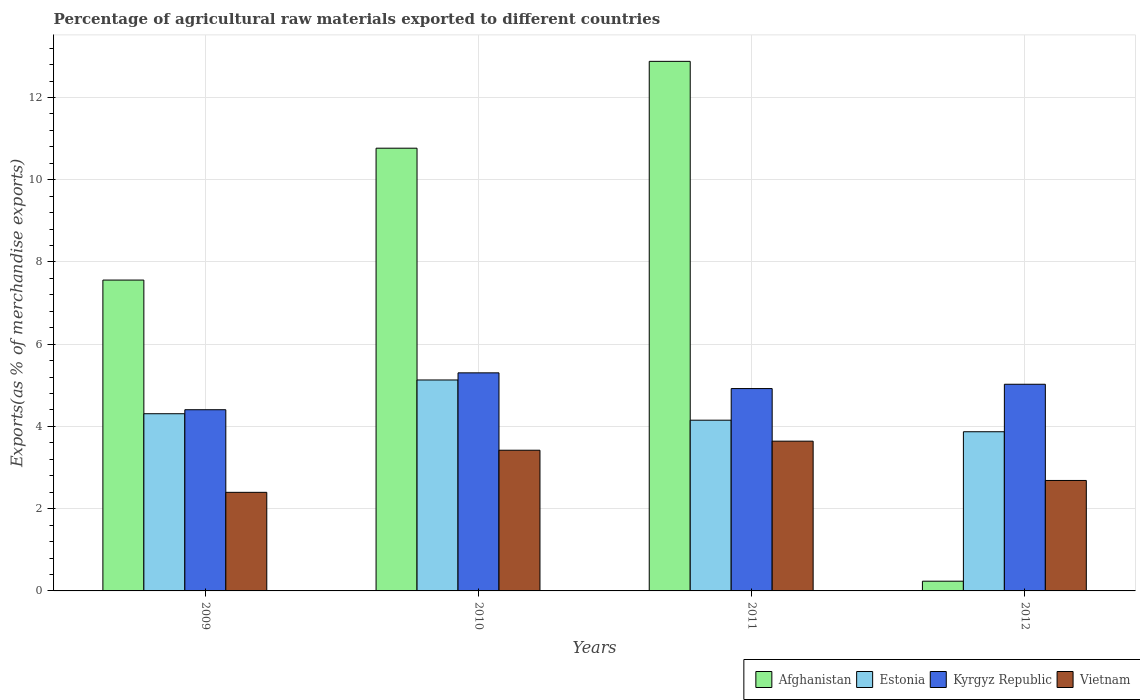How many different coloured bars are there?
Your answer should be compact. 4. Are the number of bars per tick equal to the number of legend labels?
Your answer should be compact. Yes. How many bars are there on the 4th tick from the right?
Keep it short and to the point. 4. What is the percentage of exports to different countries in Kyrgyz Republic in 2010?
Provide a succinct answer. 5.3. Across all years, what is the maximum percentage of exports to different countries in Vietnam?
Provide a short and direct response. 3.64. Across all years, what is the minimum percentage of exports to different countries in Afghanistan?
Make the answer very short. 0.24. In which year was the percentage of exports to different countries in Estonia maximum?
Give a very brief answer. 2010. What is the total percentage of exports to different countries in Afghanistan in the graph?
Your answer should be compact. 31.44. What is the difference between the percentage of exports to different countries in Kyrgyz Republic in 2009 and that in 2010?
Provide a succinct answer. -0.9. What is the difference between the percentage of exports to different countries in Estonia in 2010 and the percentage of exports to different countries in Afghanistan in 2012?
Your answer should be very brief. 4.89. What is the average percentage of exports to different countries in Estonia per year?
Your response must be concise. 4.37. In the year 2010, what is the difference between the percentage of exports to different countries in Afghanistan and percentage of exports to different countries in Kyrgyz Republic?
Provide a short and direct response. 5.46. What is the ratio of the percentage of exports to different countries in Estonia in 2010 to that in 2011?
Ensure brevity in your answer.  1.24. Is the percentage of exports to different countries in Afghanistan in 2010 less than that in 2012?
Ensure brevity in your answer.  No. What is the difference between the highest and the second highest percentage of exports to different countries in Vietnam?
Your response must be concise. 0.22. What is the difference between the highest and the lowest percentage of exports to different countries in Estonia?
Your response must be concise. 1.26. Is it the case that in every year, the sum of the percentage of exports to different countries in Kyrgyz Republic and percentage of exports to different countries in Afghanistan is greater than the sum of percentage of exports to different countries in Vietnam and percentage of exports to different countries in Estonia?
Your response must be concise. No. What does the 1st bar from the left in 2011 represents?
Provide a succinct answer. Afghanistan. What does the 1st bar from the right in 2010 represents?
Make the answer very short. Vietnam. Is it the case that in every year, the sum of the percentage of exports to different countries in Estonia and percentage of exports to different countries in Afghanistan is greater than the percentage of exports to different countries in Vietnam?
Offer a very short reply. Yes. Are all the bars in the graph horizontal?
Ensure brevity in your answer.  No. What is the difference between two consecutive major ticks on the Y-axis?
Ensure brevity in your answer.  2. Are the values on the major ticks of Y-axis written in scientific E-notation?
Provide a short and direct response. No. Does the graph contain any zero values?
Give a very brief answer. No. Does the graph contain grids?
Your answer should be compact. Yes. Where does the legend appear in the graph?
Your answer should be compact. Bottom right. How many legend labels are there?
Your response must be concise. 4. How are the legend labels stacked?
Give a very brief answer. Horizontal. What is the title of the graph?
Provide a succinct answer. Percentage of agricultural raw materials exported to different countries. What is the label or title of the Y-axis?
Ensure brevity in your answer.  Exports(as % of merchandise exports). What is the Exports(as % of merchandise exports) of Afghanistan in 2009?
Ensure brevity in your answer.  7.56. What is the Exports(as % of merchandise exports) of Estonia in 2009?
Ensure brevity in your answer.  4.31. What is the Exports(as % of merchandise exports) of Kyrgyz Republic in 2009?
Ensure brevity in your answer.  4.41. What is the Exports(as % of merchandise exports) of Vietnam in 2009?
Offer a very short reply. 2.4. What is the Exports(as % of merchandise exports) in Afghanistan in 2010?
Offer a very short reply. 10.77. What is the Exports(as % of merchandise exports) of Estonia in 2010?
Make the answer very short. 5.13. What is the Exports(as % of merchandise exports) of Kyrgyz Republic in 2010?
Provide a short and direct response. 5.3. What is the Exports(as % of merchandise exports) in Vietnam in 2010?
Your answer should be very brief. 3.42. What is the Exports(as % of merchandise exports) of Afghanistan in 2011?
Ensure brevity in your answer.  12.88. What is the Exports(as % of merchandise exports) of Estonia in 2011?
Your answer should be compact. 4.15. What is the Exports(as % of merchandise exports) of Kyrgyz Republic in 2011?
Offer a terse response. 4.92. What is the Exports(as % of merchandise exports) of Vietnam in 2011?
Provide a succinct answer. 3.64. What is the Exports(as % of merchandise exports) in Afghanistan in 2012?
Offer a terse response. 0.24. What is the Exports(as % of merchandise exports) in Estonia in 2012?
Your answer should be very brief. 3.87. What is the Exports(as % of merchandise exports) of Kyrgyz Republic in 2012?
Ensure brevity in your answer.  5.03. What is the Exports(as % of merchandise exports) of Vietnam in 2012?
Your answer should be very brief. 2.69. Across all years, what is the maximum Exports(as % of merchandise exports) in Afghanistan?
Your response must be concise. 12.88. Across all years, what is the maximum Exports(as % of merchandise exports) of Estonia?
Your answer should be very brief. 5.13. Across all years, what is the maximum Exports(as % of merchandise exports) of Kyrgyz Republic?
Your answer should be very brief. 5.3. Across all years, what is the maximum Exports(as % of merchandise exports) of Vietnam?
Provide a succinct answer. 3.64. Across all years, what is the minimum Exports(as % of merchandise exports) in Afghanistan?
Provide a succinct answer. 0.24. Across all years, what is the minimum Exports(as % of merchandise exports) of Estonia?
Provide a short and direct response. 3.87. Across all years, what is the minimum Exports(as % of merchandise exports) of Kyrgyz Republic?
Offer a terse response. 4.41. Across all years, what is the minimum Exports(as % of merchandise exports) of Vietnam?
Keep it short and to the point. 2.4. What is the total Exports(as % of merchandise exports) in Afghanistan in the graph?
Your answer should be compact. 31.44. What is the total Exports(as % of merchandise exports) in Estonia in the graph?
Ensure brevity in your answer.  17.46. What is the total Exports(as % of merchandise exports) in Kyrgyz Republic in the graph?
Offer a very short reply. 19.66. What is the total Exports(as % of merchandise exports) of Vietnam in the graph?
Provide a short and direct response. 12.15. What is the difference between the Exports(as % of merchandise exports) of Afghanistan in 2009 and that in 2010?
Keep it short and to the point. -3.21. What is the difference between the Exports(as % of merchandise exports) in Estonia in 2009 and that in 2010?
Offer a terse response. -0.82. What is the difference between the Exports(as % of merchandise exports) in Kyrgyz Republic in 2009 and that in 2010?
Make the answer very short. -0.9. What is the difference between the Exports(as % of merchandise exports) in Vietnam in 2009 and that in 2010?
Ensure brevity in your answer.  -1.02. What is the difference between the Exports(as % of merchandise exports) of Afghanistan in 2009 and that in 2011?
Offer a very short reply. -5.32. What is the difference between the Exports(as % of merchandise exports) in Estonia in 2009 and that in 2011?
Keep it short and to the point. 0.16. What is the difference between the Exports(as % of merchandise exports) of Kyrgyz Republic in 2009 and that in 2011?
Your response must be concise. -0.51. What is the difference between the Exports(as % of merchandise exports) of Vietnam in 2009 and that in 2011?
Keep it short and to the point. -1.24. What is the difference between the Exports(as % of merchandise exports) of Afghanistan in 2009 and that in 2012?
Your answer should be very brief. 7.32. What is the difference between the Exports(as % of merchandise exports) of Estonia in 2009 and that in 2012?
Your answer should be very brief. 0.44. What is the difference between the Exports(as % of merchandise exports) in Kyrgyz Republic in 2009 and that in 2012?
Offer a terse response. -0.62. What is the difference between the Exports(as % of merchandise exports) of Vietnam in 2009 and that in 2012?
Your answer should be very brief. -0.29. What is the difference between the Exports(as % of merchandise exports) of Afghanistan in 2010 and that in 2011?
Offer a terse response. -2.11. What is the difference between the Exports(as % of merchandise exports) of Estonia in 2010 and that in 2011?
Provide a succinct answer. 0.98. What is the difference between the Exports(as % of merchandise exports) in Kyrgyz Republic in 2010 and that in 2011?
Your response must be concise. 0.38. What is the difference between the Exports(as % of merchandise exports) in Vietnam in 2010 and that in 2011?
Make the answer very short. -0.22. What is the difference between the Exports(as % of merchandise exports) in Afghanistan in 2010 and that in 2012?
Keep it short and to the point. 10.53. What is the difference between the Exports(as % of merchandise exports) of Estonia in 2010 and that in 2012?
Provide a short and direct response. 1.26. What is the difference between the Exports(as % of merchandise exports) in Kyrgyz Republic in 2010 and that in 2012?
Provide a succinct answer. 0.28. What is the difference between the Exports(as % of merchandise exports) of Vietnam in 2010 and that in 2012?
Offer a very short reply. 0.74. What is the difference between the Exports(as % of merchandise exports) in Afghanistan in 2011 and that in 2012?
Ensure brevity in your answer.  12.64. What is the difference between the Exports(as % of merchandise exports) in Estonia in 2011 and that in 2012?
Provide a short and direct response. 0.28. What is the difference between the Exports(as % of merchandise exports) of Kyrgyz Republic in 2011 and that in 2012?
Your answer should be very brief. -0.11. What is the difference between the Exports(as % of merchandise exports) in Vietnam in 2011 and that in 2012?
Your response must be concise. 0.96. What is the difference between the Exports(as % of merchandise exports) of Afghanistan in 2009 and the Exports(as % of merchandise exports) of Estonia in 2010?
Your response must be concise. 2.43. What is the difference between the Exports(as % of merchandise exports) in Afghanistan in 2009 and the Exports(as % of merchandise exports) in Kyrgyz Republic in 2010?
Give a very brief answer. 2.26. What is the difference between the Exports(as % of merchandise exports) of Afghanistan in 2009 and the Exports(as % of merchandise exports) of Vietnam in 2010?
Offer a very short reply. 4.14. What is the difference between the Exports(as % of merchandise exports) in Estonia in 2009 and the Exports(as % of merchandise exports) in Kyrgyz Republic in 2010?
Make the answer very short. -0.99. What is the difference between the Exports(as % of merchandise exports) in Estonia in 2009 and the Exports(as % of merchandise exports) in Vietnam in 2010?
Your answer should be very brief. 0.89. What is the difference between the Exports(as % of merchandise exports) of Kyrgyz Republic in 2009 and the Exports(as % of merchandise exports) of Vietnam in 2010?
Ensure brevity in your answer.  0.99. What is the difference between the Exports(as % of merchandise exports) in Afghanistan in 2009 and the Exports(as % of merchandise exports) in Estonia in 2011?
Ensure brevity in your answer.  3.41. What is the difference between the Exports(as % of merchandise exports) in Afghanistan in 2009 and the Exports(as % of merchandise exports) in Kyrgyz Republic in 2011?
Keep it short and to the point. 2.64. What is the difference between the Exports(as % of merchandise exports) of Afghanistan in 2009 and the Exports(as % of merchandise exports) of Vietnam in 2011?
Your answer should be very brief. 3.92. What is the difference between the Exports(as % of merchandise exports) in Estonia in 2009 and the Exports(as % of merchandise exports) in Kyrgyz Republic in 2011?
Make the answer very short. -0.61. What is the difference between the Exports(as % of merchandise exports) of Estonia in 2009 and the Exports(as % of merchandise exports) of Vietnam in 2011?
Offer a terse response. 0.67. What is the difference between the Exports(as % of merchandise exports) of Kyrgyz Republic in 2009 and the Exports(as % of merchandise exports) of Vietnam in 2011?
Your answer should be compact. 0.76. What is the difference between the Exports(as % of merchandise exports) in Afghanistan in 2009 and the Exports(as % of merchandise exports) in Estonia in 2012?
Offer a terse response. 3.69. What is the difference between the Exports(as % of merchandise exports) in Afghanistan in 2009 and the Exports(as % of merchandise exports) in Kyrgyz Republic in 2012?
Make the answer very short. 2.53. What is the difference between the Exports(as % of merchandise exports) of Afghanistan in 2009 and the Exports(as % of merchandise exports) of Vietnam in 2012?
Ensure brevity in your answer.  4.87. What is the difference between the Exports(as % of merchandise exports) in Estonia in 2009 and the Exports(as % of merchandise exports) in Kyrgyz Republic in 2012?
Offer a terse response. -0.72. What is the difference between the Exports(as % of merchandise exports) in Estonia in 2009 and the Exports(as % of merchandise exports) in Vietnam in 2012?
Your response must be concise. 1.62. What is the difference between the Exports(as % of merchandise exports) in Kyrgyz Republic in 2009 and the Exports(as % of merchandise exports) in Vietnam in 2012?
Make the answer very short. 1.72. What is the difference between the Exports(as % of merchandise exports) of Afghanistan in 2010 and the Exports(as % of merchandise exports) of Estonia in 2011?
Your answer should be compact. 6.62. What is the difference between the Exports(as % of merchandise exports) in Afghanistan in 2010 and the Exports(as % of merchandise exports) in Kyrgyz Republic in 2011?
Your response must be concise. 5.85. What is the difference between the Exports(as % of merchandise exports) in Afghanistan in 2010 and the Exports(as % of merchandise exports) in Vietnam in 2011?
Give a very brief answer. 7.12. What is the difference between the Exports(as % of merchandise exports) in Estonia in 2010 and the Exports(as % of merchandise exports) in Kyrgyz Republic in 2011?
Ensure brevity in your answer.  0.21. What is the difference between the Exports(as % of merchandise exports) of Estonia in 2010 and the Exports(as % of merchandise exports) of Vietnam in 2011?
Your answer should be compact. 1.49. What is the difference between the Exports(as % of merchandise exports) in Kyrgyz Republic in 2010 and the Exports(as % of merchandise exports) in Vietnam in 2011?
Keep it short and to the point. 1.66. What is the difference between the Exports(as % of merchandise exports) in Afghanistan in 2010 and the Exports(as % of merchandise exports) in Estonia in 2012?
Offer a terse response. 6.9. What is the difference between the Exports(as % of merchandise exports) of Afghanistan in 2010 and the Exports(as % of merchandise exports) of Kyrgyz Republic in 2012?
Your answer should be compact. 5.74. What is the difference between the Exports(as % of merchandise exports) of Afghanistan in 2010 and the Exports(as % of merchandise exports) of Vietnam in 2012?
Offer a very short reply. 8.08. What is the difference between the Exports(as % of merchandise exports) of Estonia in 2010 and the Exports(as % of merchandise exports) of Kyrgyz Republic in 2012?
Ensure brevity in your answer.  0.1. What is the difference between the Exports(as % of merchandise exports) in Estonia in 2010 and the Exports(as % of merchandise exports) in Vietnam in 2012?
Your response must be concise. 2.44. What is the difference between the Exports(as % of merchandise exports) of Kyrgyz Republic in 2010 and the Exports(as % of merchandise exports) of Vietnam in 2012?
Your answer should be compact. 2.62. What is the difference between the Exports(as % of merchandise exports) in Afghanistan in 2011 and the Exports(as % of merchandise exports) in Estonia in 2012?
Offer a very short reply. 9.01. What is the difference between the Exports(as % of merchandise exports) of Afghanistan in 2011 and the Exports(as % of merchandise exports) of Kyrgyz Republic in 2012?
Provide a short and direct response. 7.85. What is the difference between the Exports(as % of merchandise exports) in Afghanistan in 2011 and the Exports(as % of merchandise exports) in Vietnam in 2012?
Your answer should be very brief. 10.19. What is the difference between the Exports(as % of merchandise exports) of Estonia in 2011 and the Exports(as % of merchandise exports) of Kyrgyz Republic in 2012?
Your answer should be compact. -0.87. What is the difference between the Exports(as % of merchandise exports) of Estonia in 2011 and the Exports(as % of merchandise exports) of Vietnam in 2012?
Make the answer very short. 1.47. What is the difference between the Exports(as % of merchandise exports) in Kyrgyz Republic in 2011 and the Exports(as % of merchandise exports) in Vietnam in 2012?
Your answer should be compact. 2.23. What is the average Exports(as % of merchandise exports) of Afghanistan per year?
Provide a short and direct response. 7.86. What is the average Exports(as % of merchandise exports) of Estonia per year?
Ensure brevity in your answer.  4.37. What is the average Exports(as % of merchandise exports) of Kyrgyz Republic per year?
Provide a short and direct response. 4.91. What is the average Exports(as % of merchandise exports) of Vietnam per year?
Provide a succinct answer. 3.04. In the year 2009, what is the difference between the Exports(as % of merchandise exports) in Afghanistan and Exports(as % of merchandise exports) in Estonia?
Make the answer very short. 3.25. In the year 2009, what is the difference between the Exports(as % of merchandise exports) of Afghanistan and Exports(as % of merchandise exports) of Kyrgyz Republic?
Make the answer very short. 3.15. In the year 2009, what is the difference between the Exports(as % of merchandise exports) of Afghanistan and Exports(as % of merchandise exports) of Vietnam?
Provide a short and direct response. 5.16. In the year 2009, what is the difference between the Exports(as % of merchandise exports) of Estonia and Exports(as % of merchandise exports) of Kyrgyz Republic?
Offer a terse response. -0.1. In the year 2009, what is the difference between the Exports(as % of merchandise exports) in Estonia and Exports(as % of merchandise exports) in Vietnam?
Your answer should be very brief. 1.91. In the year 2009, what is the difference between the Exports(as % of merchandise exports) in Kyrgyz Republic and Exports(as % of merchandise exports) in Vietnam?
Provide a succinct answer. 2.01. In the year 2010, what is the difference between the Exports(as % of merchandise exports) of Afghanistan and Exports(as % of merchandise exports) of Estonia?
Offer a very short reply. 5.64. In the year 2010, what is the difference between the Exports(as % of merchandise exports) in Afghanistan and Exports(as % of merchandise exports) in Kyrgyz Republic?
Ensure brevity in your answer.  5.46. In the year 2010, what is the difference between the Exports(as % of merchandise exports) of Afghanistan and Exports(as % of merchandise exports) of Vietnam?
Your answer should be compact. 7.35. In the year 2010, what is the difference between the Exports(as % of merchandise exports) in Estonia and Exports(as % of merchandise exports) in Kyrgyz Republic?
Keep it short and to the point. -0.17. In the year 2010, what is the difference between the Exports(as % of merchandise exports) of Estonia and Exports(as % of merchandise exports) of Vietnam?
Make the answer very short. 1.71. In the year 2010, what is the difference between the Exports(as % of merchandise exports) in Kyrgyz Republic and Exports(as % of merchandise exports) in Vietnam?
Offer a terse response. 1.88. In the year 2011, what is the difference between the Exports(as % of merchandise exports) in Afghanistan and Exports(as % of merchandise exports) in Estonia?
Give a very brief answer. 8.73. In the year 2011, what is the difference between the Exports(as % of merchandise exports) of Afghanistan and Exports(as % of merchandise exports) of Kyrgyz Republic?
Offer a very short reply. 7.96. In the year 2011, what is the difference between the Exports(as % of merchandise exports) in Afghanistan and Exports(as % of merchandise exports) in Vietnam?
Provide a short and direct response. 9.24. In the year 2011, what is the difference between the Exports(as % of merchandise exports) in Estonia and Exports(as % of merchandise exports) in Kyrgyz Republic?
Offer a very short reply. -0.77. In the year 2011, what is the difference between the Exports(as % of merchandise exports) in Estonia and Exports(as % of merchandise exports) in Vietnam?
Your response must be concise. 0.51. In the year 2011, what is the difference between the Exports(as % of merchandise exports) of Kyrgyz Republic and Exports(as % of merchandise exports) of Vietnam?
Offer a very short reply. 1.28. In the year 2012, what is the difference between the Exports(as % of merchandise exports) of Afghanistan and Exports(as % of merchandise exports) of Estonia?
Your answer should be compact. -3.63. In the year 2012, what is the difference between the Exports(as % of merchandise exports) of Afghanistan and Exports(as % of merchandise exports) of Kyrgyz Republic?
Ensure brevity in your answer.  -4.79. In the year 2012, what is the difference between the Exports(as % of merchandise exports) in Afghanistan and Exports(as % of merchandise exports) in Vietnam?
Your answer should be compact. -2.45. In the year 2012, what is the difference between the Exports(as % of merchandise exports) of Estonia and Exports(as % of merchandise exports) of Kyrgyz Republic?
Your answer should be compact. -1.15. In the year 2012, what is the difference between the Exports(as % of merchandise exports) in Estonia and Exports(as % of merchandise exports) in Vietnam?
Keep it short and to the point. 1.19. In the year 2012, what is the difference between the Exports(as % of merchandise exports) of Kyrgyz Republic and Exports(as % of merchandise exports) of Vietnam?
Provide a short and direct response. 2.34. What is the ratio of the Exports(as % of merchandise exports) in Afghanistan in 2009 to that in 2010?
Keep it short and to the point. 0.7. What is the ratio of the Exports(as % of merchandise exports) in Estonia in 2009 to that in 2010?
Provide a short and direct response. 0.84. What is the ratio of the Exports(as % of merchandise exports) of Kyrgyz Republic in 2009 to that in 2010?
Offer a terse response. 0.83. What is the ratio of the Exports(as % of merchandise exports) in Vietnam in 2009 to that in 2010?
Ensure brevity in your answer.  0.7. What is the ratio of the Exports(as % of merchandise exports) in Afghanistan in 2009 to that in 2011?
Make the answer very short. 0.59. What is the ratio of the Exports(as % of merchandise exports) of Estonia in 2009 to that in 2011?
Your answer should be compact. 1.04. What is the ratio of the Exports(as % of merchandise exports) in Kyrgyz Republic in 2009 to that in 2011?
Offer a very short reply. 0.9. What is the ratio of the Exports(as % of merchandise exports) in Vietnam in 2009 to that in 2011?
Offer a terse response. 0.66. What is the ratio of the Exports(as % of merchandise exports) in Afghanistan in 2009 to that in 2012?
Offer a terse response. 31.95. What is the ratio of the Exports(as % of merchandise exports) of Estonia in 2009 to that in 2012?
Keep it short and to the point. 1.11. What is the ratio of the Exports(as % of merchandise exports) in Kyrgyz Republic in 2009 to that in 2012?
Provide a short and direct response. 0.88. What is the ratio of the Exports(as % of merchandise exports) in Vietnam in 2009 to that in 2012?
Keep it short and to the point. 0.89. What is the ratio of the Exports(as % of merchandise exports) in Afghanistan in 2010 to that in 2011?
Your response must be concise. 0.84. What is the ratio of the Exports(as % of merchandise exports) of Estonia in 2010 to that in 2011?
Make the answer very short. 1.24. What is the ratio of the Exports(as % of merchandise exports) in Kyrgyz Republic in 2010 to that in 2011?
Offer a very short reply. 1.08. What is the ratio of the Exports(as % of merchandise exports) of Vietnam in 2010 to that in 2011?
Your response must be concise. 0.94. What is the ratio of the Exports(as % of merchandise exports) of Afghanistan in 2010 to that in 2012?
Offer a terse response. 45.51. What is the ratio of the Exports(as % of merchandise exports) of Estonia in 2010 to that in 2012?
Provide a succinct answer. 1.33. What is the ratio of the Exports(as % of merchandise exports) of Kyrgyz Republic in 2010 to that in 2012?
Your response must be concise. 1.06. What is the ratio of the Exports(as % of merchandise exports) in Vietnam in 2010 to that in 2012?
Ensure brevity in your answer.  1.27. What is the ratio of the Exports(as % of merchandise exports) of Afghanistan in 2011 to that in 2012?
Give a very brief answer. 54.43. What is the ratio of the Exports(as % of merchandise exports) in Estonia in 2011 to that in 2012?
Your answer should be compact. 1.07. What is the ratio of the Exports(as % of merchandise exports) of Kyrgyz Republic in 2011 to that in 2012?
Give a very brief answer. 0.98. What is the ratio of the Exports(as % of merchandise exports) in Vietnam in 2011 to that in 2012?
Provide a succinct answer. 1.36. What is the difference between the highest and the second highest Exports(as % of merchandise exports) of Afghanistan?
Provide a succinct answer. 2.11. What is the difference between the highest and the second highest Exports(as % of merchandise exports) in Estonia?
Offer a terse response. 0.82. What is the difference between the highest and the second highest Exports(as % of merchandise exports) of Kyrgyz Republic?
Your answer should be very brief. 0.28. What is the difference between the highest and the second highest Exports(as % of merchandise exports) of Vietnam?
Give a very brief answer. 0.22. What is the difference between the highest and the lowest Exports(as % of merchandise exports) in Afghanistan?
Offer a terse response. 12.64. What is the difference between the highest and the lowest Exports(as % of merchandise exports) in Estonia?
Provide a succinct answer. 1.26. What is the difference between the highest and the lowest Exports(as % of merchandise exports) in Kyrgyz Republic?
Provide a short and direct response. 0.9. What is the difference between the highest and the lowest Exports(as % of merchandise exports) in Vietnam?
Offer a very short reply. 1.24. 